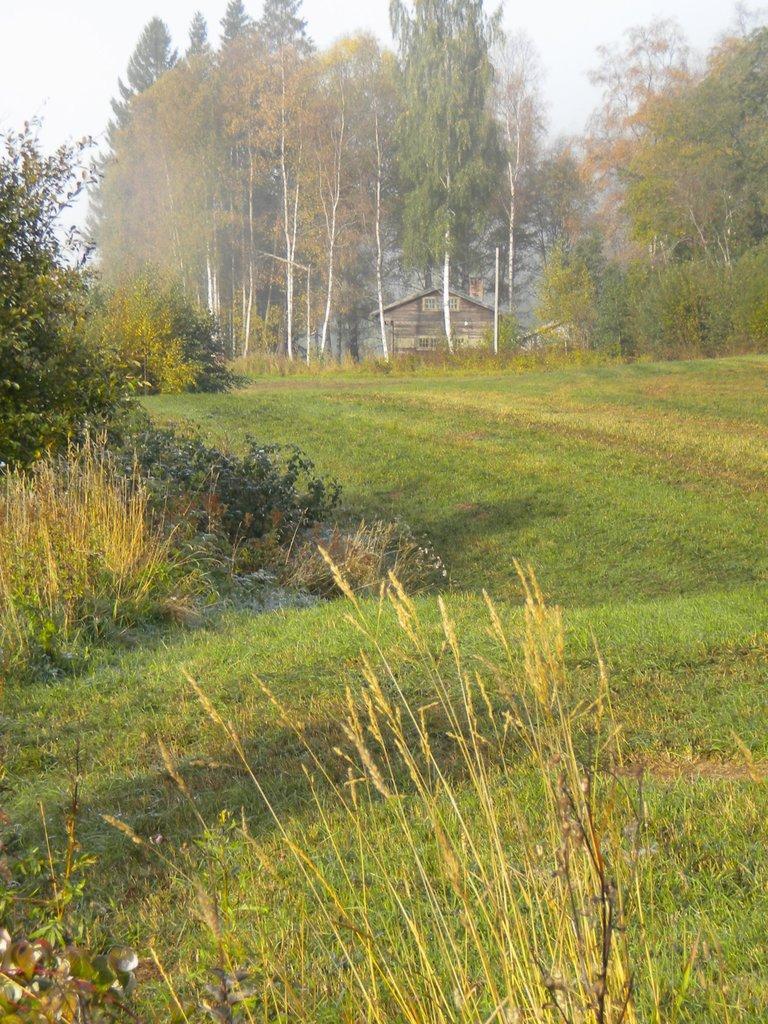Can you describe this image briefly? These are trees and grass, this is house and a sky. 